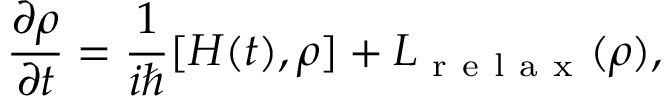<formula> <loc_0><loc_0><loc_500><loc_500>\frac { \partial \rho } { \partial t } = \frac { 1 } { i } [ H ( t ) , \rho ] + L _ { r e l a x } ( \rho ) ,</formula> 